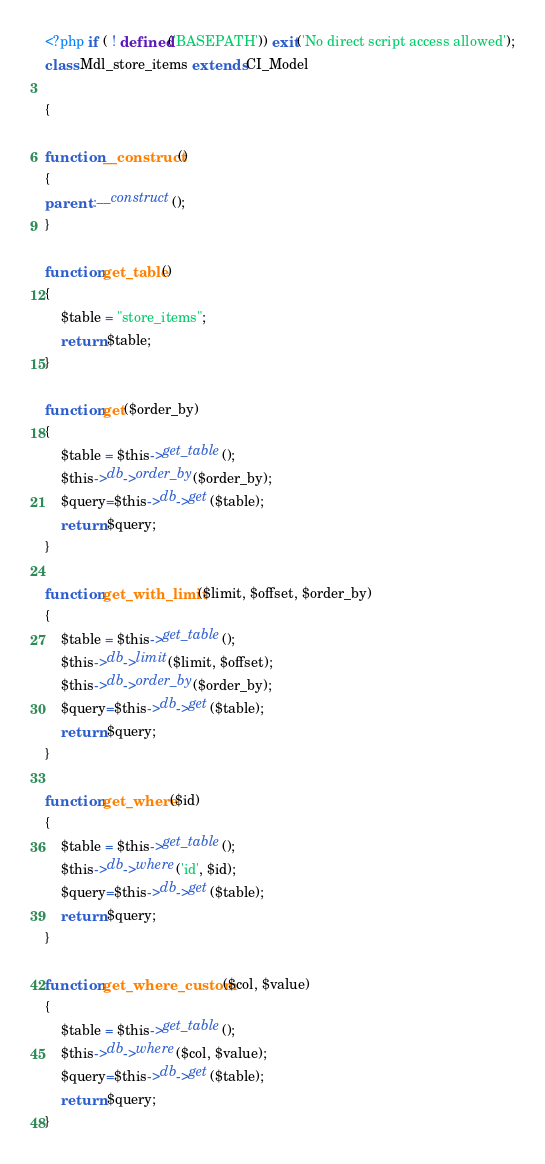Convert code to text. <code><loc_0><loc_0><loc_500><loc_500><_PHP_><?php if ( ! defined('BASEPATH')) exit('No direct script access allowed');
class Mdl_store_items extends CI_Model

{

function __construct() 
{
parent::__construct();
}

function get_table() 
{
    $table = "store_items";
    return $table;
}

function get($order_by)
{
    $table = $this->get_table();
    $this->db->order_by($order_by);
    $query=$this->db->get($table);
    return $query;
}

function get_with_limit($limit, $offset, $order_by) 
{
    $table = $this->get_table();
    $this->db->limit($limit, $offset);
    $this->db->order_by($order_by);
    $query=$this->db->get($table);
    return $query;
}

function get_where($id)
{
    $table = $this->get_table();
    $this->db->where('id', $id);
    $query=$this->db->get($table);
    return $query;
}

function get_where_custom($col, $value) 
{
    $table = $this->get_table();
    $this->db->where($col, $value);
    $query=$this->db->get($table);
    return $query;
}
</code> 